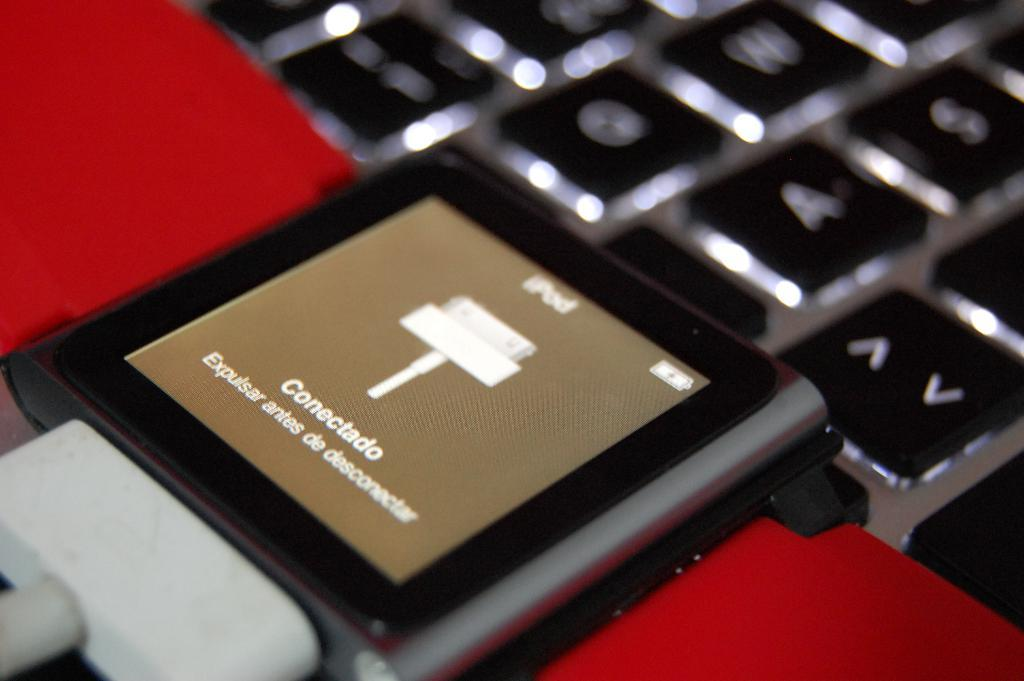<image>
Describe the image concisely. The iPod screen reads "Conectado" over a brown background. 